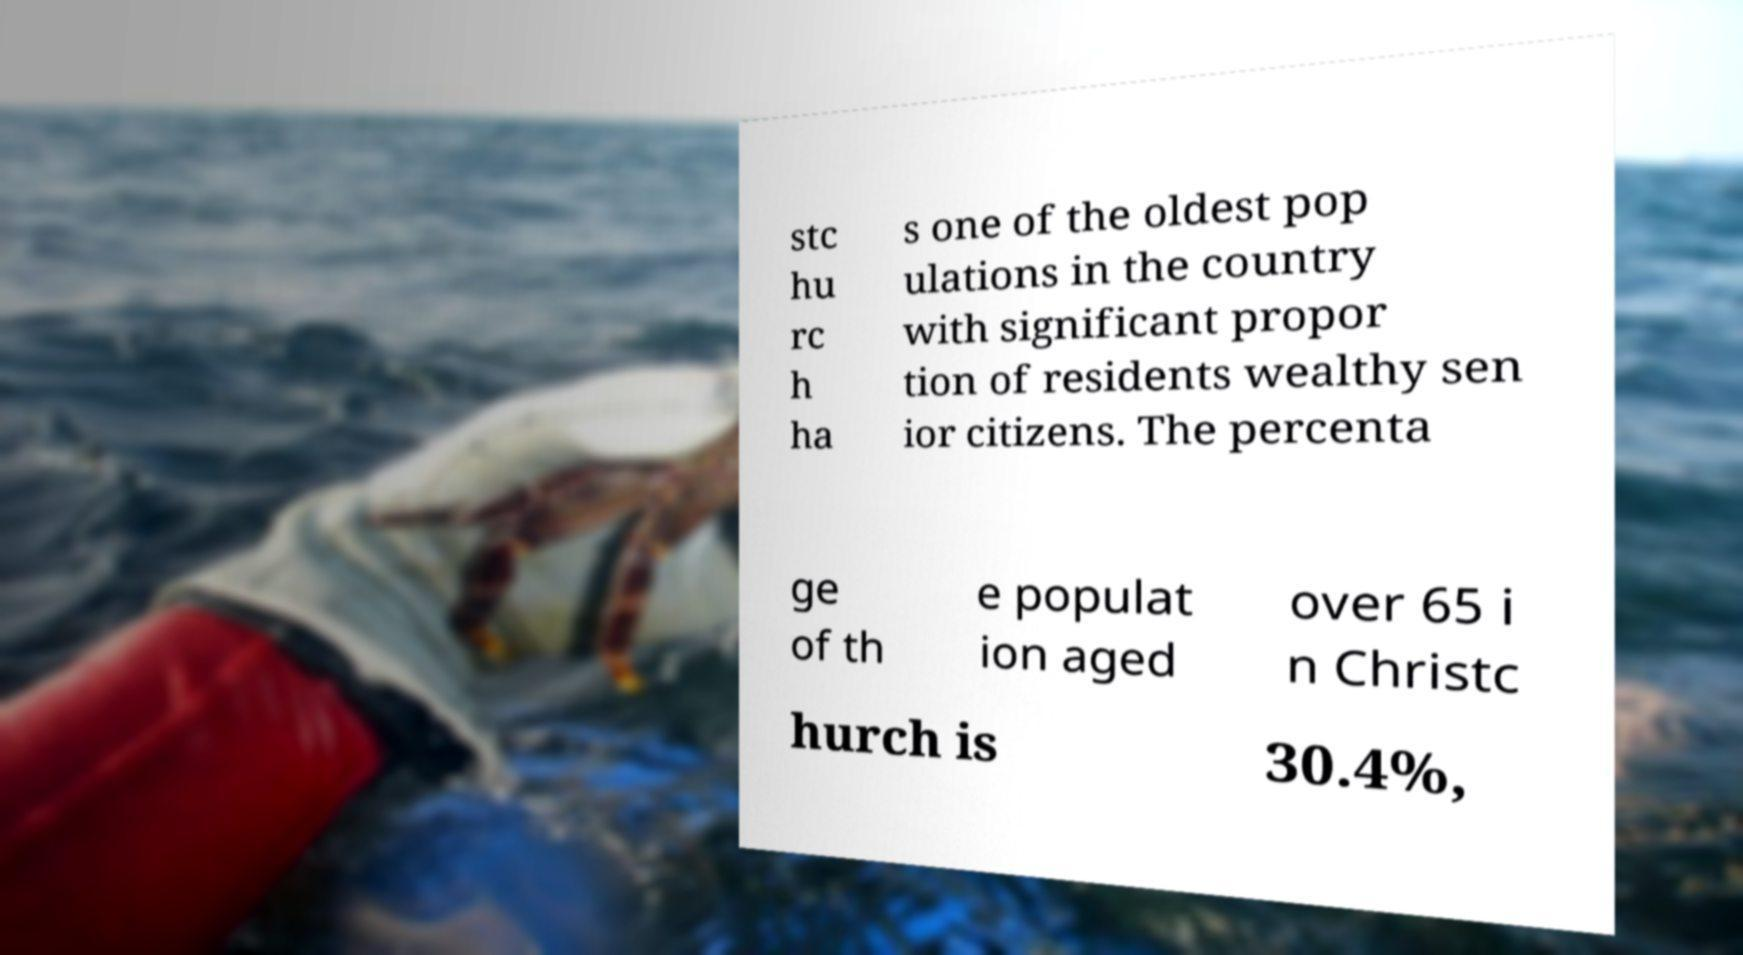For documentation purposes, I need the text within this image transcribed. Could you provide that? stc hu rc h ha s one of the oldest pop ulations in the country with significant propor tion of residents wealthy sen ior citizens. The percenta ge of th e populat ion aged over 65 i n Christc hurch is 30.4%, 